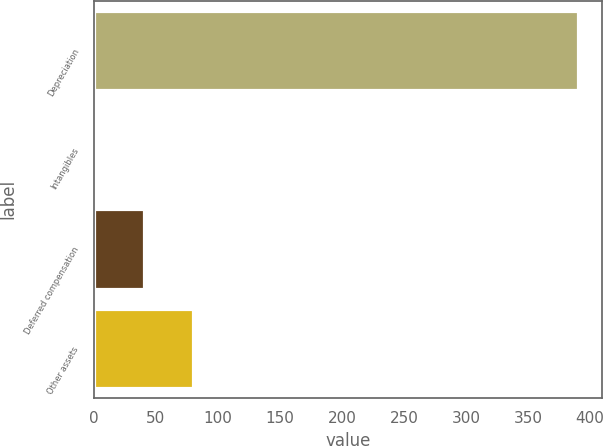<chart> <loc_0><loc_0><loc_500><loc_500><bar_chart><fcel>Depreciation<fcel>Intangibles<fcel>Deferred compensation<fcel>Other assets<nl><fcel>390<fcel>2<fcel>40.8<fcel>79.6<nl></chart> 